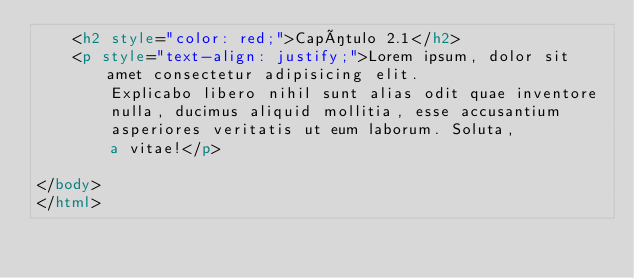Convert code to text. <code><loc_0><loc_0><loc_500><loc_500><_HTML_>    <h2 style="color: red;">Capítulo 2.1</h2>
    <p style="text-align: justify;">Lorem ipsum, dolor sit amet consectetur adipisicing elit. 
        Explicabo libero nihil sunt alias odit quae inventore 
        nulla, ducimus aliquid mollitia, esse accusantium 
        asperiores veritatis ut eum laborum. Soluta, 
        a vitae!</p>
    
</body>
</html></code> 